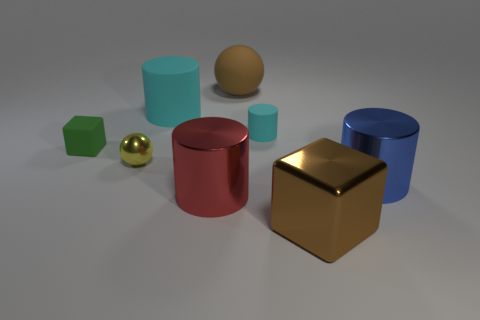Subtract all cyan cylinders. How many cylinders are left? 2 Subtract all small rubber cylinders. How many cylinders are left? 3 Subtract all cubes. How many objects are left? 6 Subtract 1 cylinders. How many cylinders are left? 3 Add 7 tiny green rubber cylinders. How many tiny green rubber cylinders exist? 7 Add 1 large brown blocks. How many objects exist? 9 Subtract 0 blue blocks. How many objects are left? 8 Subtract all yellow balls. Subtract all purple cylinders. How many balls are left? 1 Subtract all green balls. How many brown cylinders are left? 0 Subtract all blue things. Subtract all small balls. How many objects are left? 6 